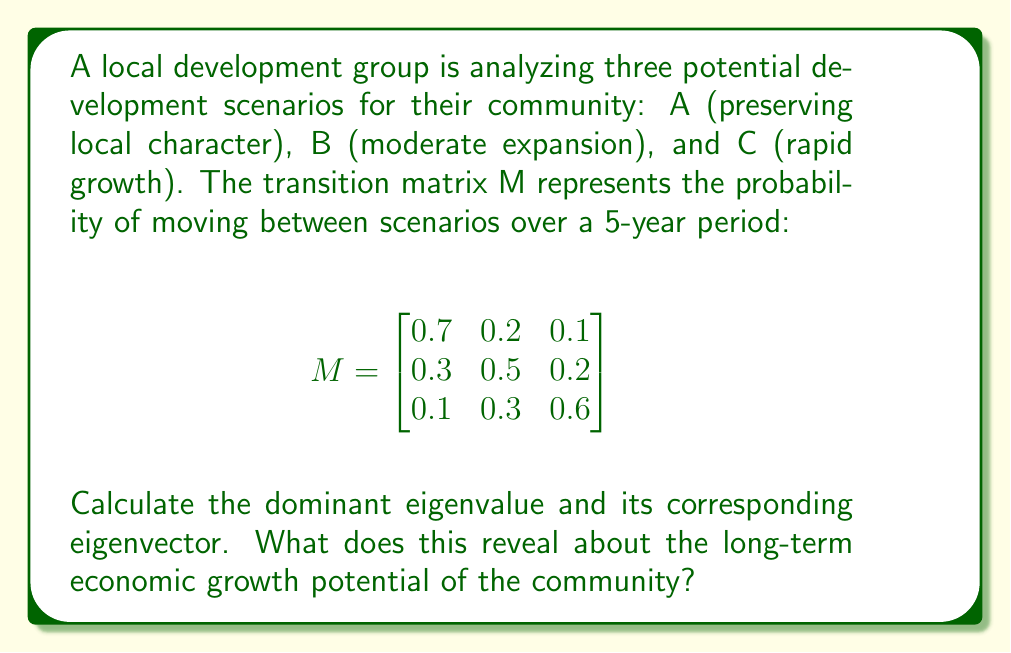Provide a solution to this math problem. 1. To find the eigenvalues, we solve the characteristic equation:
   $$det(M - \lambda I) = 0$$

2. Expanding the determinant:
   $$(0.7 - \lambda)(0.5 - \lambda)(0.6 - \lambda) - 0.1 \cdot 0.2 \cdot 0.3 - 0.1 \cdot 0.2 \cdot 0.3 = 0$$

3. Simplifying:
   $$-\lambda^3 + 1.8\lambda^2 - 0.97\lambda + 0.158 = 0$$

4. Solving this equation (using a calculator or computer algebra system) gives us the eigenvalues:
   $$\lambda_1 \approx 1, \lambda_2 \approx 0.5, \lambda_3 \approx 0.3$$

5. The dominant eigenvalue is $\lambda_1 \approx 1$.

6. To find the corresponding eigenvector $\mathbf{v}$, we solve:
   $$(M - \lambda_1 I)\mathbf{v} = \mathbf{0}$$

7. Substituting and solving (again, using a computer algebra system for precision):
   $$\mathbf{v} \approx [0.5, 0.33, 0.17]^T$$

8. Normalizing the eigenvector:
   $$\mathbf{v} \approx [0.5, 0.33, 0.17]^T$$

9. Interpretation: The dominant eigenvalue being close to 1 indicates stability in the long term. The corresponding eigenvector represents the steady-state distribution of scenarios:
   - Scenario A (preserving local character): 50%
   - Scenario B (moderate expansion): 33%
   - Scenario C (rapid growth): 17%

This suggests that, in the long term, the community is most likely to maintain its local character while allowing for some moderate expansion, with a smaller probability of rapid growth.
Answer: Dominant eigenvalue: 1. Eigenvector: [0.5, 0.33, 0.17]. Long-term: 50% local character, 33% moderate expansion, 17% rapid growth. 